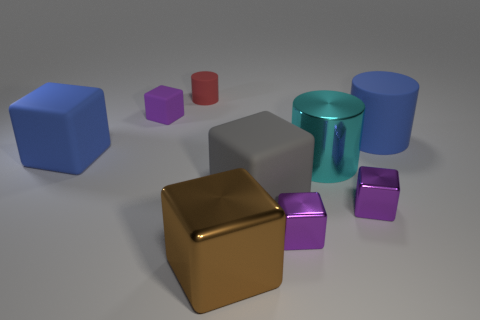Subtract all purple cubes. How many were subtracted if there are1purple cubes left? 2 Subtract all big cylinders. How many cylinders are left? 1 Subtract all cyan cylinders. How many purple cubes are left? 3 Subtract all brown cubes. How many cubes are left? 5 Subtract 3 blocks. How many blocks are left? 3 Add 1 red cylinders. How many objects exist? 10 Subtract all cubes. How many objects are left? 3 Add 9 small red metallic things. How many small red metallic things exist? 9 Subtract 1 brown blocks. How many objects are left? 8 Subtract all red cubes. Subtract all brown cylinders. How many cubes are left? 6 